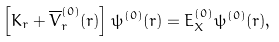<formula> <loc_0><loc_0><loc_500><loc_500>\left [ K _ { r } + \overline { V } ^ { ( 0 ) } _ { r } ( r ) \right ] \psi ^ { ( 0 ) } ( r ) = E ^ { ( 0 ) } _ { X } \psi ^ { ( 0 ) } ( r ) , \\</formula> 